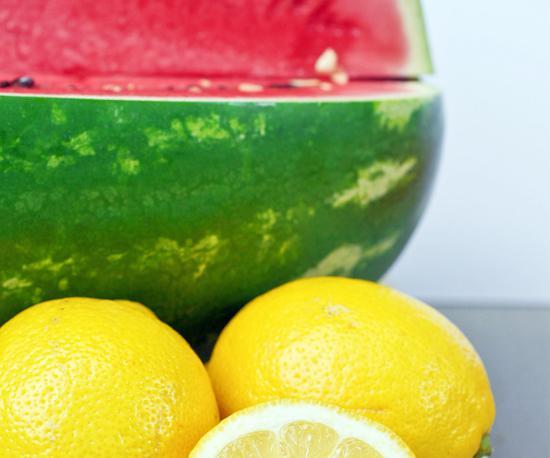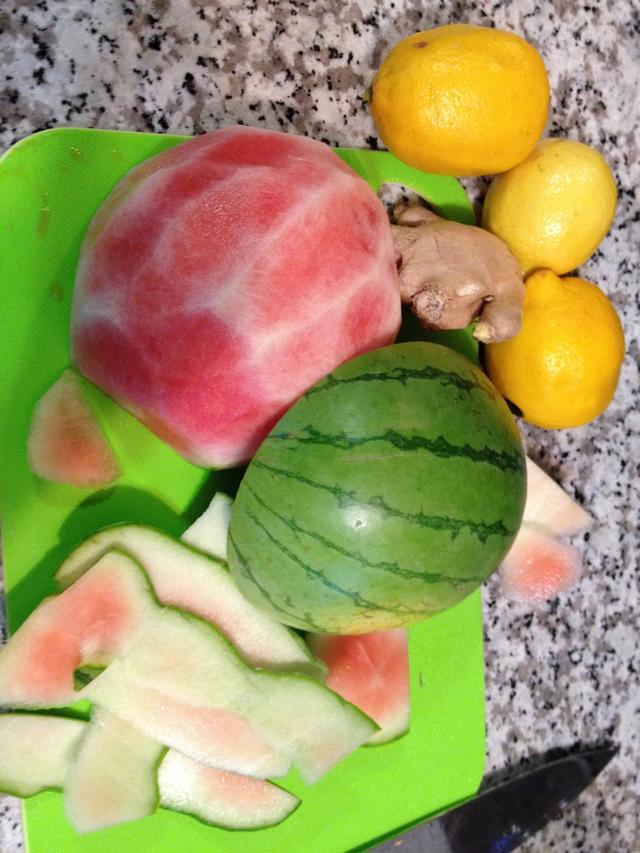The first image is the image on the left, the second image is the image on the right. Examine the images to the left and right. Is the description "In one image, a red drink in a canning jar has at least one straw." accurate? Answer yes or no. No. The first image is the image on the left, the second image is the image on the right. Assess this claim about the two images: "There is a straw with pink swirl in a drink.". Correct or not? Answer yes or no. No. 